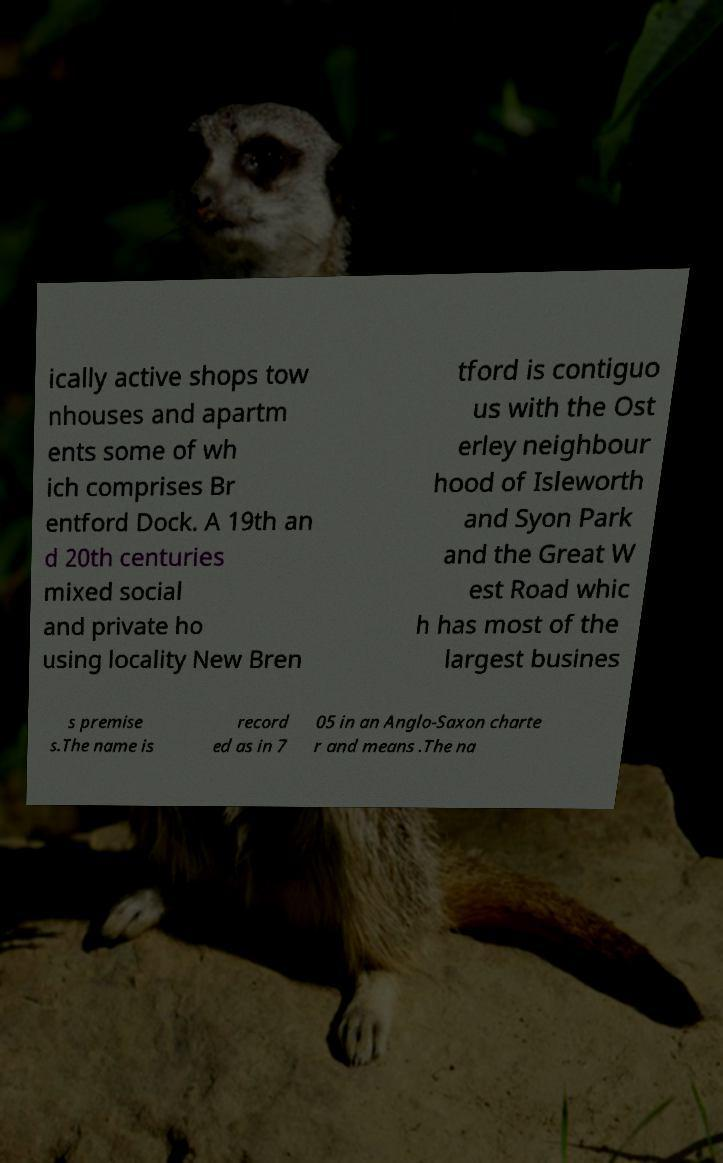Could you extract and type out the text from this image? ically active shops tow nhouses and apartm ents some of wh ich comprises Br entford Dock. A 19th an d 20th centuries mixed social and private ho using locality New Bren tford is contiguo us with the Ost erley neighbour hood of Isleworth and Syon Park and the Great W est Road whic h has most of the largest busines s premise s.The name is record ed as in 7 05 in an Anglo-Saxon charte r and means .The na 